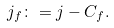<formula> <loc_0><loc_0><loc_500><loc_500>j _ { f } \colon = j - C _ { f } .</formula> 